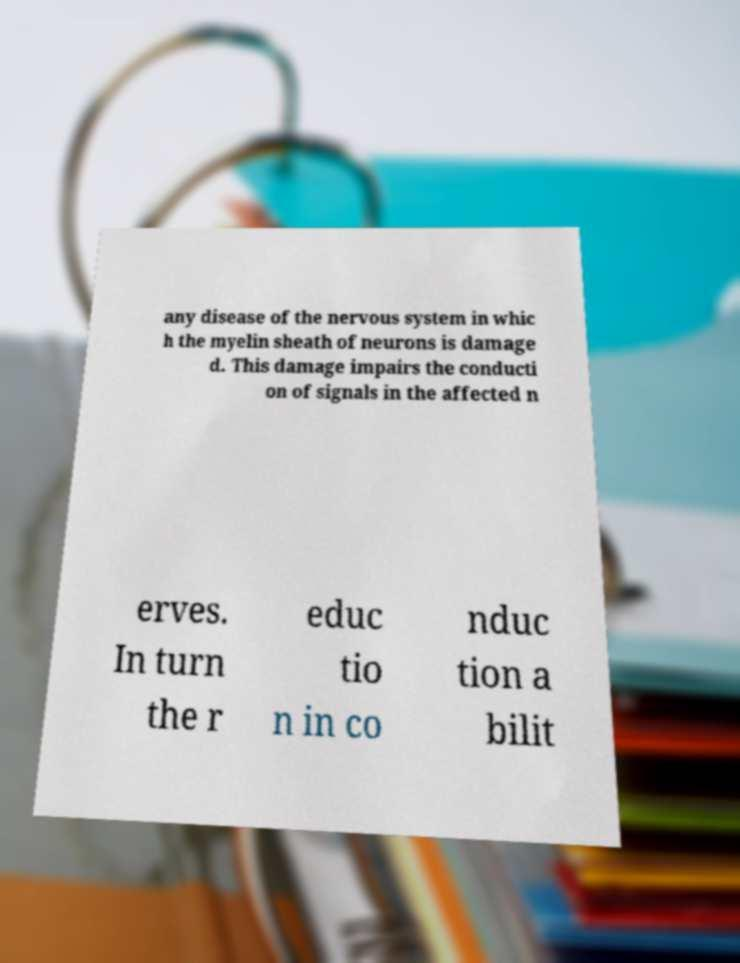I need the written content from this picture converted into text. Can you do that? any disease of the nervous system in whic h the myelin sheath of neurons is damage d. This damage impairs the conducti on of signals in the affected n erves. In turn the r educ tio n in co nduc tion a bilit 